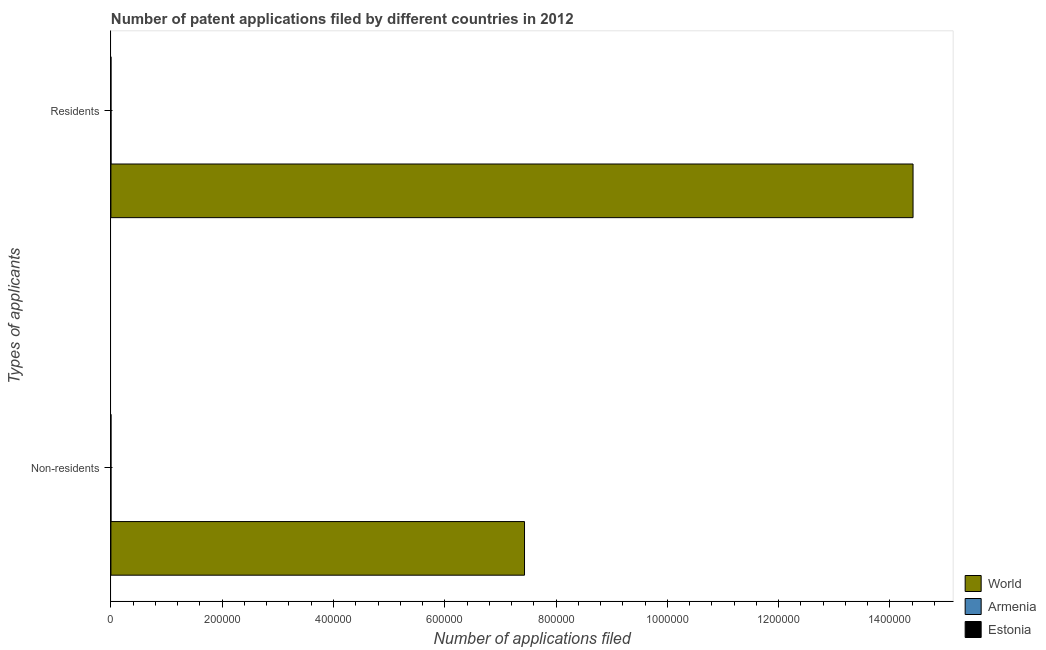How many groups of bars are there?
Make the answer very short. 2. Are the number of bars on each tick of the Y-axis equal?
Make the answer very short. Yes. How many bars are there on the 1st tick from the top?
Keep it short and to the point. 3. How many bars are there on the 1st tick from the bottom?
Give a very brief answer. 3. What is the label of the 1st group of bars from the top?
Your response must be concise. Residents. What is the number of patent applications by non residents in World?
Provide a succinct answer. 7.43e+05. Across all countries, what is the maximum number of patent applications by residents?
Your answer should be compact. 1.44e+06. Across all countries, what is the minimum number of patent applications by residents?
Ensure brevity in your answer.  20. In which country was the number of patent applications by non residents maximum?
Provide a succinct answer. World. In which country was the number of patent applications by residents minimum?
Provide a short and direct response. Estonia. What is the total number of patent applications by non residents in the graph?
Provide a succinct answer. 7.43e+05. What is the difference between the number of patent applications by residents in Estonia and that in Armenia?
Give a very brief answer. -117. What is the difference between the number of patent applications by non residents in World and the number of patent applications by residents in Estonia?
Provide a succinct answer. 7.43e+05. What is the average number of patent applications by residents per country?
Your answer should be compact. 4.81e+05. What is the difference between the number of patent applications by residents and number of patent applications by non residents in Estonia?
Keep it short and to the point. 15. In how many countries, is the number of patent applications by non residents greater than 160000 ?
Keep it short and to the point. 1. What is the ratio of the number of patent applications by residents in Estonia to that in World?
Your answer should be compact. 1.3874773234174954e-5. Is the number of patent applications by residents in Estonia less than that in Armenia?
Offer a very short reply. Yes. In how many countries, is the number of patent applications by residents greater than the average number of patent applications by residents taken over all countries?
Ensure brevity in your answer.  1. What does the 3rd bar from the top in Non-residents represents?
Your answer should be compact. World. What does the 3rd bar from the bottom in Non-residents represents?
Ensure brevity in your answer.  Estonia. How many bars are there?
Your answer should be very brief. 6. How many countries are there in the graph?
Offer a very short reply. 3. Are the values on the major ticks of X-axis written in scientific E-notation?
Give a very brief answer. No. Where does the legend appear in the graph?
Your answer should be compact. Bottom right. What is the title of the graph?
Your response must be concise. Number of patent applications filed by different countries in 2012. What is the label or title of the X-axis?
Provide a short and direct response. Number of applications filed. What is the label or title of the Y-axis?
Ensure brevity in your answer.  Types of applicants. What is the Number of applications filed in World in Non-residents?
Give a very brief answer. 7.43e+05. What is the Number of applications filed of Estonia in Non-residents?
Your answer should be very brief. 5. What is the Number of applications filed of World in Residents?
Your answer should be compact. 1.44e+06. What is the Number of applications filed of Armenia in Residents?
Give a very brief answer. 137. Across all Types of applicants, what is the maximum Number of applications filed of World?
Your answer should be compact. 1.44e+06. Across all Types of applicants, what is the maximum Number of applications filed in Armenia?
Your answer should be very brief. 137. Across all Types of applicants, what is the maximum Number of applications filed in Estonia?
Keep it short and to the point. 20. Across all Types of applicants, what is the minimum Number of applications filed in World?
Keep it short and to the point. 7.43e+05. Across all Types of applicants, what is the minimum Number of applications filed in Armenia?
Provide a succinct answer. 4. Across all Types of applicants, what is the minimum Number of applications filed in Estonia?
Keep it short and to the point. 5. What is the total Number of applications filed in World in the graph?
Your answer should be compact. 2.18e+06. What is the total Number of applications filed of Armenia in the graph?
Your response must be concise. 141. What is the difference between the Number of applications filed in World in Non-residents and that in Residents?
Make the answer very short. -6.98e+05. What is the difference between the Number of applications filed of Armenia in Non-residents and that in Residents?
Keep it short and to the point. -133. What is the difference between the Number of applications filed in Estonia in Non-residents and that in Residents?
Offer a terse response. -15. What is the difference between the Number of applications filed of World in Non-residents and the Number of applications filed of Armenia in Residents?
Make the answer very short. 7.43e+05. What is the difference between the Number of applications filed in World in Non-residents and the Number of applications filed in Estonia in Residents?
Offer a terse response. 7.43e+05. What is the difference between the Number of applications filed of Armenia in Non-residents and the Number of applications filed of Estonia in Residents?
Provide a succinct answer. -16. What is the average Number of applications filed of World per Types of applicants?
Your answer should be compact. 1.09e+06. What is the average Number of applications filed in Armenia per Types of applicants?
Offer a very short reply. 70.5. What is the difference between the Number of applications filed of World and Number of applications filed of Armenia in Non-residents?
Make the answer very short. 7.43e+05. What is the difference between the Number of applications filed in World and Number of applications filed in Estonia in Non-residents?
Offer a terse response. 7.43e+05. What is the difference between the Number of applications filed of World and Number of applications filed of Armenia in Residents?
Offer a very short reply. 1.44e+06. What is the difference between the Number of applications filed in World and Number of applications filed in Estonia in Residents?
Provide a succinct answer. 1.44e+06. What is the difference between the Number of applications filed of Armenia and Number of applications filed of Estonia in Residents?
Provide a short and direct response. 117. What is the ratio of the Number of applications filed in World in Non-residents to that in Residents?
Keep it short and to the point. 0.52. What is the ratio of the Number of applications filed in Armenia in Non-residents to that in Residents?
Provide a short and direct response. 0.03. What is the difference between the highest and the second highest Number of applications filed of World?
Make the answer very short. 6.98e+05. What is the difference between the highest and the second highest Number of applications filed in Armenia?
Give a very brief answer. 133. What is the difference between the highest and the second highest Number of applications filed of Estonia?
Provide a short and direct response. 15. What is the difference between the highest and the lowest Number of applications filed in World?
Make the answer very short. 6.98e+05. What is the difference between the highest and the lowest Number of applications filed in Armenia?
Provide a succinct answer. 133. 